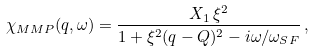<formula> <loc_0><loc_0><loc_500><loc_500>\chi _ { M M P } ( q , \omega ) = \frac { X _ { 1 } \, \xi ^ { 2 } } { 1 + \xi ^ { 2 } ( q - Q ) ^ { 2 } - i \omega / \omega _ { S F } } \, ,</formula> 